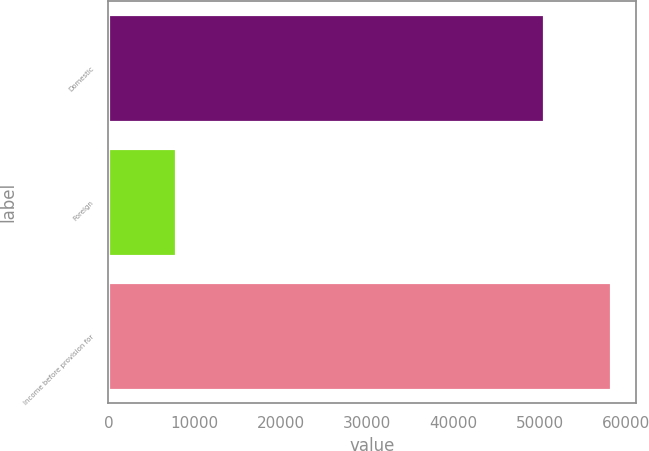Convert chart to OTSL. <chart><loc_0><loc_0><loc_500><loc_500><bar_chart><fcel>Domestic<fcel>Foreign<fcel>Income before provision for<nl><fcel>50455<fcel>7820<fcel>58275<nl></chart> 